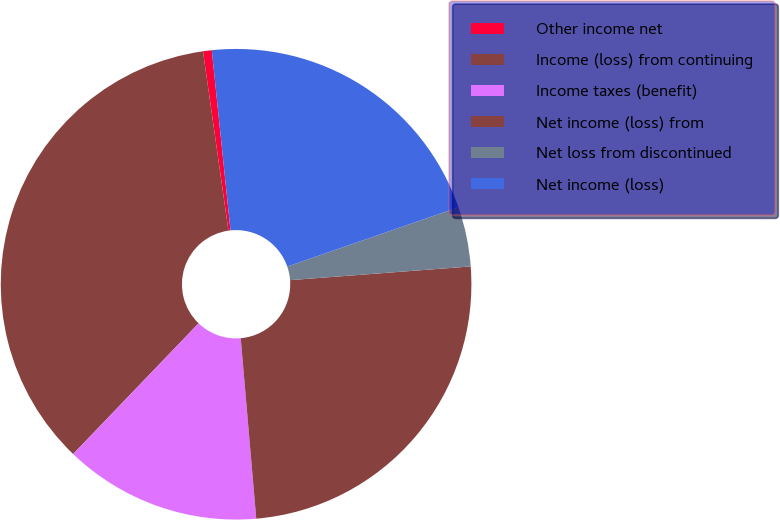<chart> <loc_0><loc_0><loc_500><loc_500><pie_chart><fcel>Other income net<fcel>Income (loss) from continuing<fcel>Income taxes (benefit)<fcel>Net income (loss) from<fcel>Net loss from discontinued<fcel>Net income (loss)<nl><fcel>0.6%<fcel>35.58%<fcel>13.54%<fcel>24.84%<fcel>4.1%<fcel>21.34%<nl></chart> 